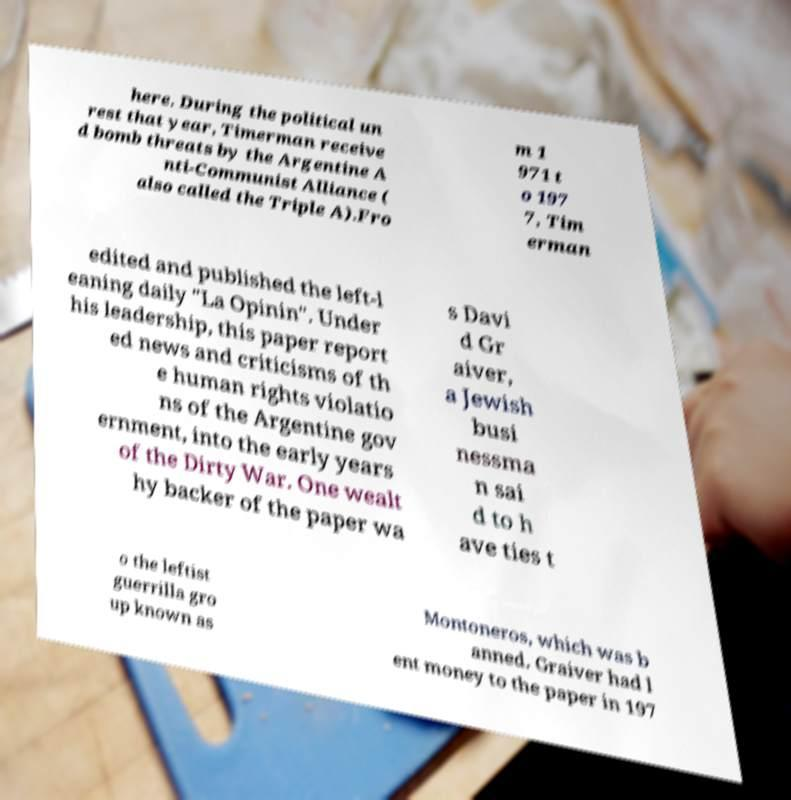There's text embedded in this image that I need extracted. Can you transcribe it verbatim? here. During the political un rest that year, Timerman receive d bomb threats by the Argentine A nti-Communist Alliance ( also called the Triple A).Fro m 1 971 t o 197 7, Tim erman edited and published the left-l eaning daily "La Opinin". Under his leadership, this paper report ed news and criticisms of th e human rights violatio ns of the Argentine gov ernment, into the early years of the Dirty War. One wealt hy backer of the paper wa s Davi d Gr aiver, a Jewish busi nessma n sai d to h ave ties t o the leftist guerrilla gro up known as Montoneros, which was b anned. Graiver had l ent money to the paper in 197 